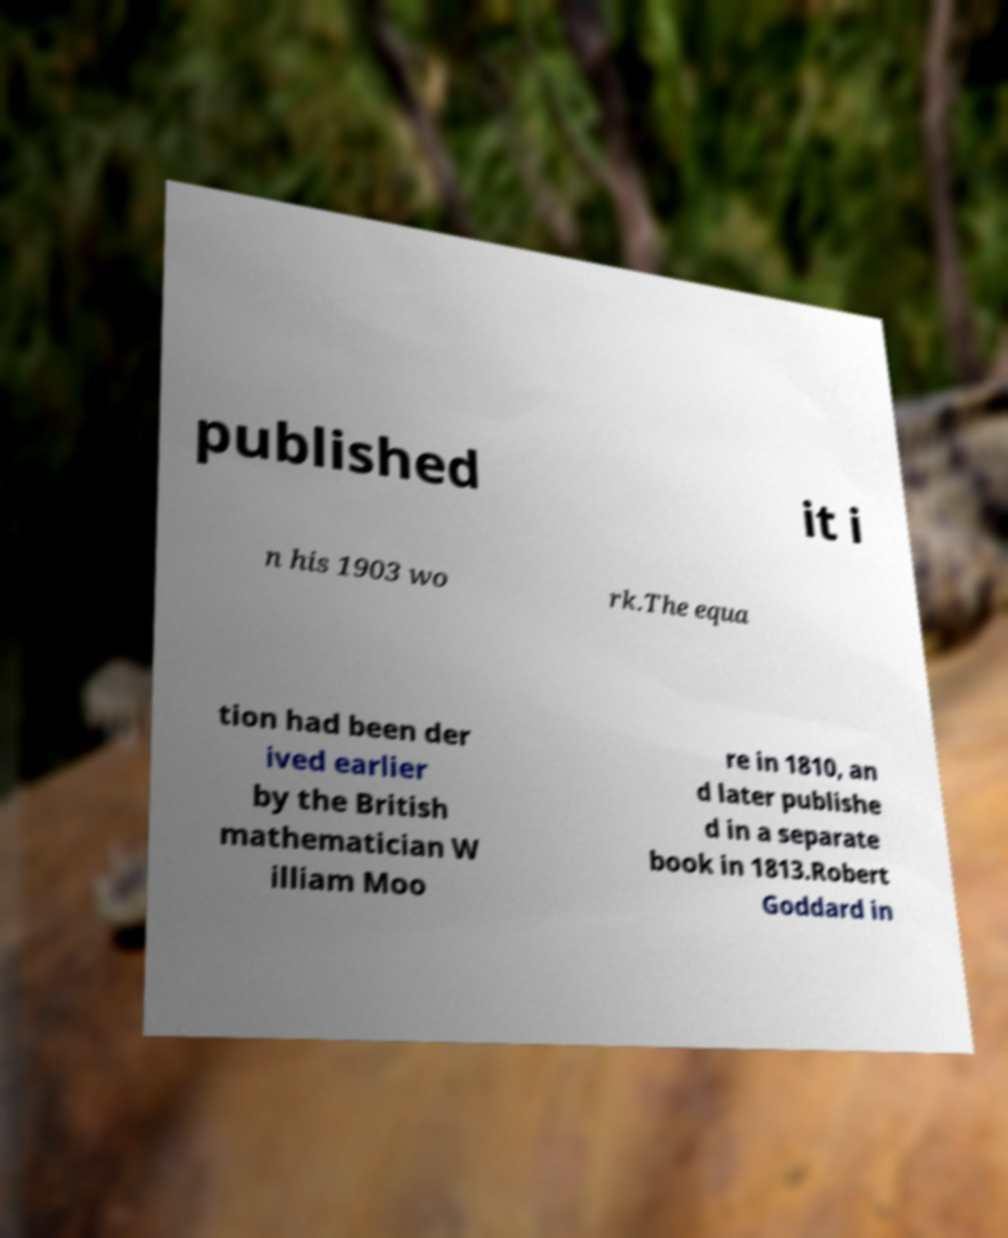Could you assist in decoding the text presented in this image and type it out clearly? published it i n his 1903 wo rk.The equa tion had been der ived earlier by the British mathematician W illiam Moo re in 1810, an d later publishe d in a separate book in 1813.Robert Goddard in 